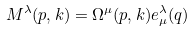Convert formula to latex. <formula><loc_0><loc_0><loc_500><loc_500>M ^ { \lambda } ( p , k ) = \Omega ^ { \mu } ( p , k ) e _ { \mu } ^ { \lambda } ( q )</formula> 